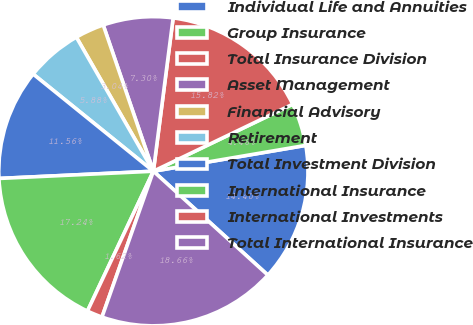<chart> <loc_0><loc_0><loc_500><loc_500><pie_chart><fcel>Individual Life and Annuities<fcel>Group Insurance<fcel>Total Insurance Division<fcel>Asset Management<fcel>Financial Advisory<fcel>Retirement<fcel>Total Investment Division<fcel>International Insurance<fcel>International Investments<fcel>Total International Insurance<nl><fcel>14.4%<fcel>4.46%<fcel>15.82%<fcel>7.3%<fcel>3.04%<fcel>5.88%<fcel>11.56%<fcel>17.24%<fcel>1.62%<fcel>18.66%<nl></chart> 